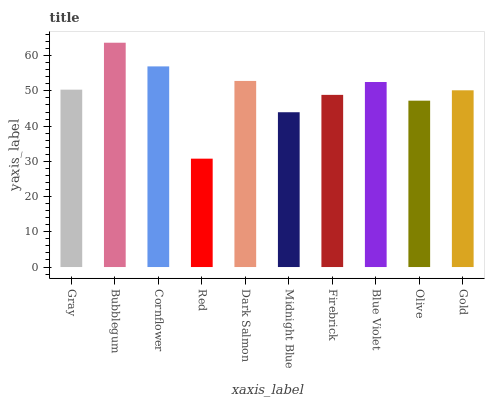Is Red the minimum?
Answer yes or no. Yes. Is Bubblegum the maximum?
Answer yes or no. Yes. Is Cornflower the minimum?
Answer yes or no. No. Is Cornflower the maximum?
Answer yes or no. No. Is Bubblegum greater than Cornflower?
Answer yes or no. Yes. Is Cornflower less than Bubblegum?
Answer yes or no. Yes. Is Cornflower greater than Bubblegum?
Answer yes or no. No. Is Bubblegum less than Cornflower?
Answer yes or no. No. Is Gray the high median?
Answer yes or no. Yes. Is Gold the low median?
Answer yes or no. Yes. Is Blue Violet the high median?
Answer yes or no. No. Is Bubblegum the low median?
Answer yes or no. No. 